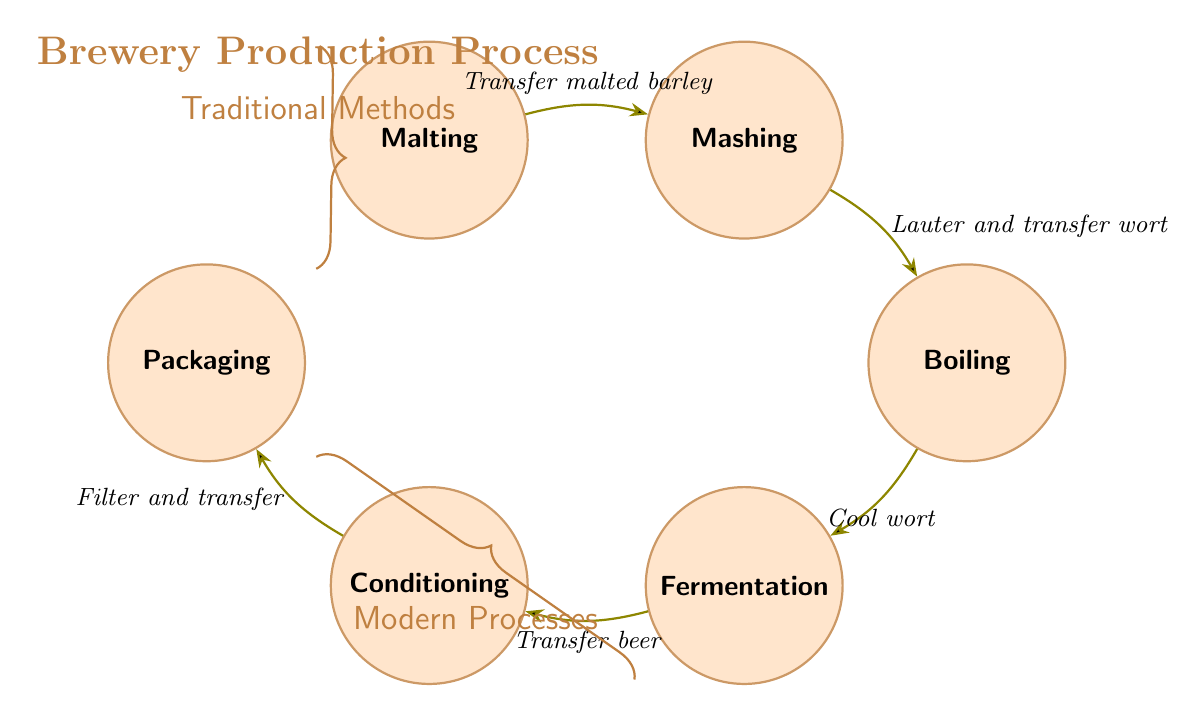What is the first state in the production process? The first state listed in the diagram is "Malting," which is where the brewery starts its production process.
Answer: Malting How many total states are present in the diagram? There are six states in the diagram: Malting, Mashing, Boiling, Fermentation, Conditioning, and Packaging. Counting these states gives a total of six.
Answer: 6 What action follows Mashing? Mashing transitions to Boiling, with the action described as "Lauter and transfer wort to kettle." This means the next step after Mashing is Boiling.
Answer: Boiling What is the last action before Packaging? The last action before reaching the Packaging state is "Filter and transfer beer to packaging line," which represents the final step in preparing the beer for distribution.
Answer: Filter and transfer Which state involves adding yeast? The state involving adding yeast to the wort is "Fermentation." Here, the sugars from the wort are transformed into alcohol and carbonation through the action of yeast.
Answer: Fermentation Describe the transition between Boiling and Fermentation. The transition from Boiling to Fermentation involves the action of "Cool wort and transfer to fermenter." This describes the cooling of the boiled wort before adding it to the fermentation vessel.
Answer: Cool wort How do Traditional Methods and Modern Processes differ in this workflow? Traditional Methods encompass the entire process from Malting to Packaging, while Modern Processes specifically highlight the steps from Fermentation to Packaging. Traditional Methods emphasize natural and time-honored practices, whereas Modern Processes may suggest equipment and techniques for efficiency.
Answer: Traditional Methods; Modern Processes What happens after Conditioning? After Conditioning, the process moves to Packaging, where the matured beer is filtered and prepared for bottling or kegging. This step is important for ensuring the final product is ready for distribution.
Answer: Packaging Which state requires the maturing process? The state that requires maturing is "Conditioning." During this phase, the fermented beer develops its flavors and clarity, which is essential for the final quality of the beer.
Answer: Conditioning 